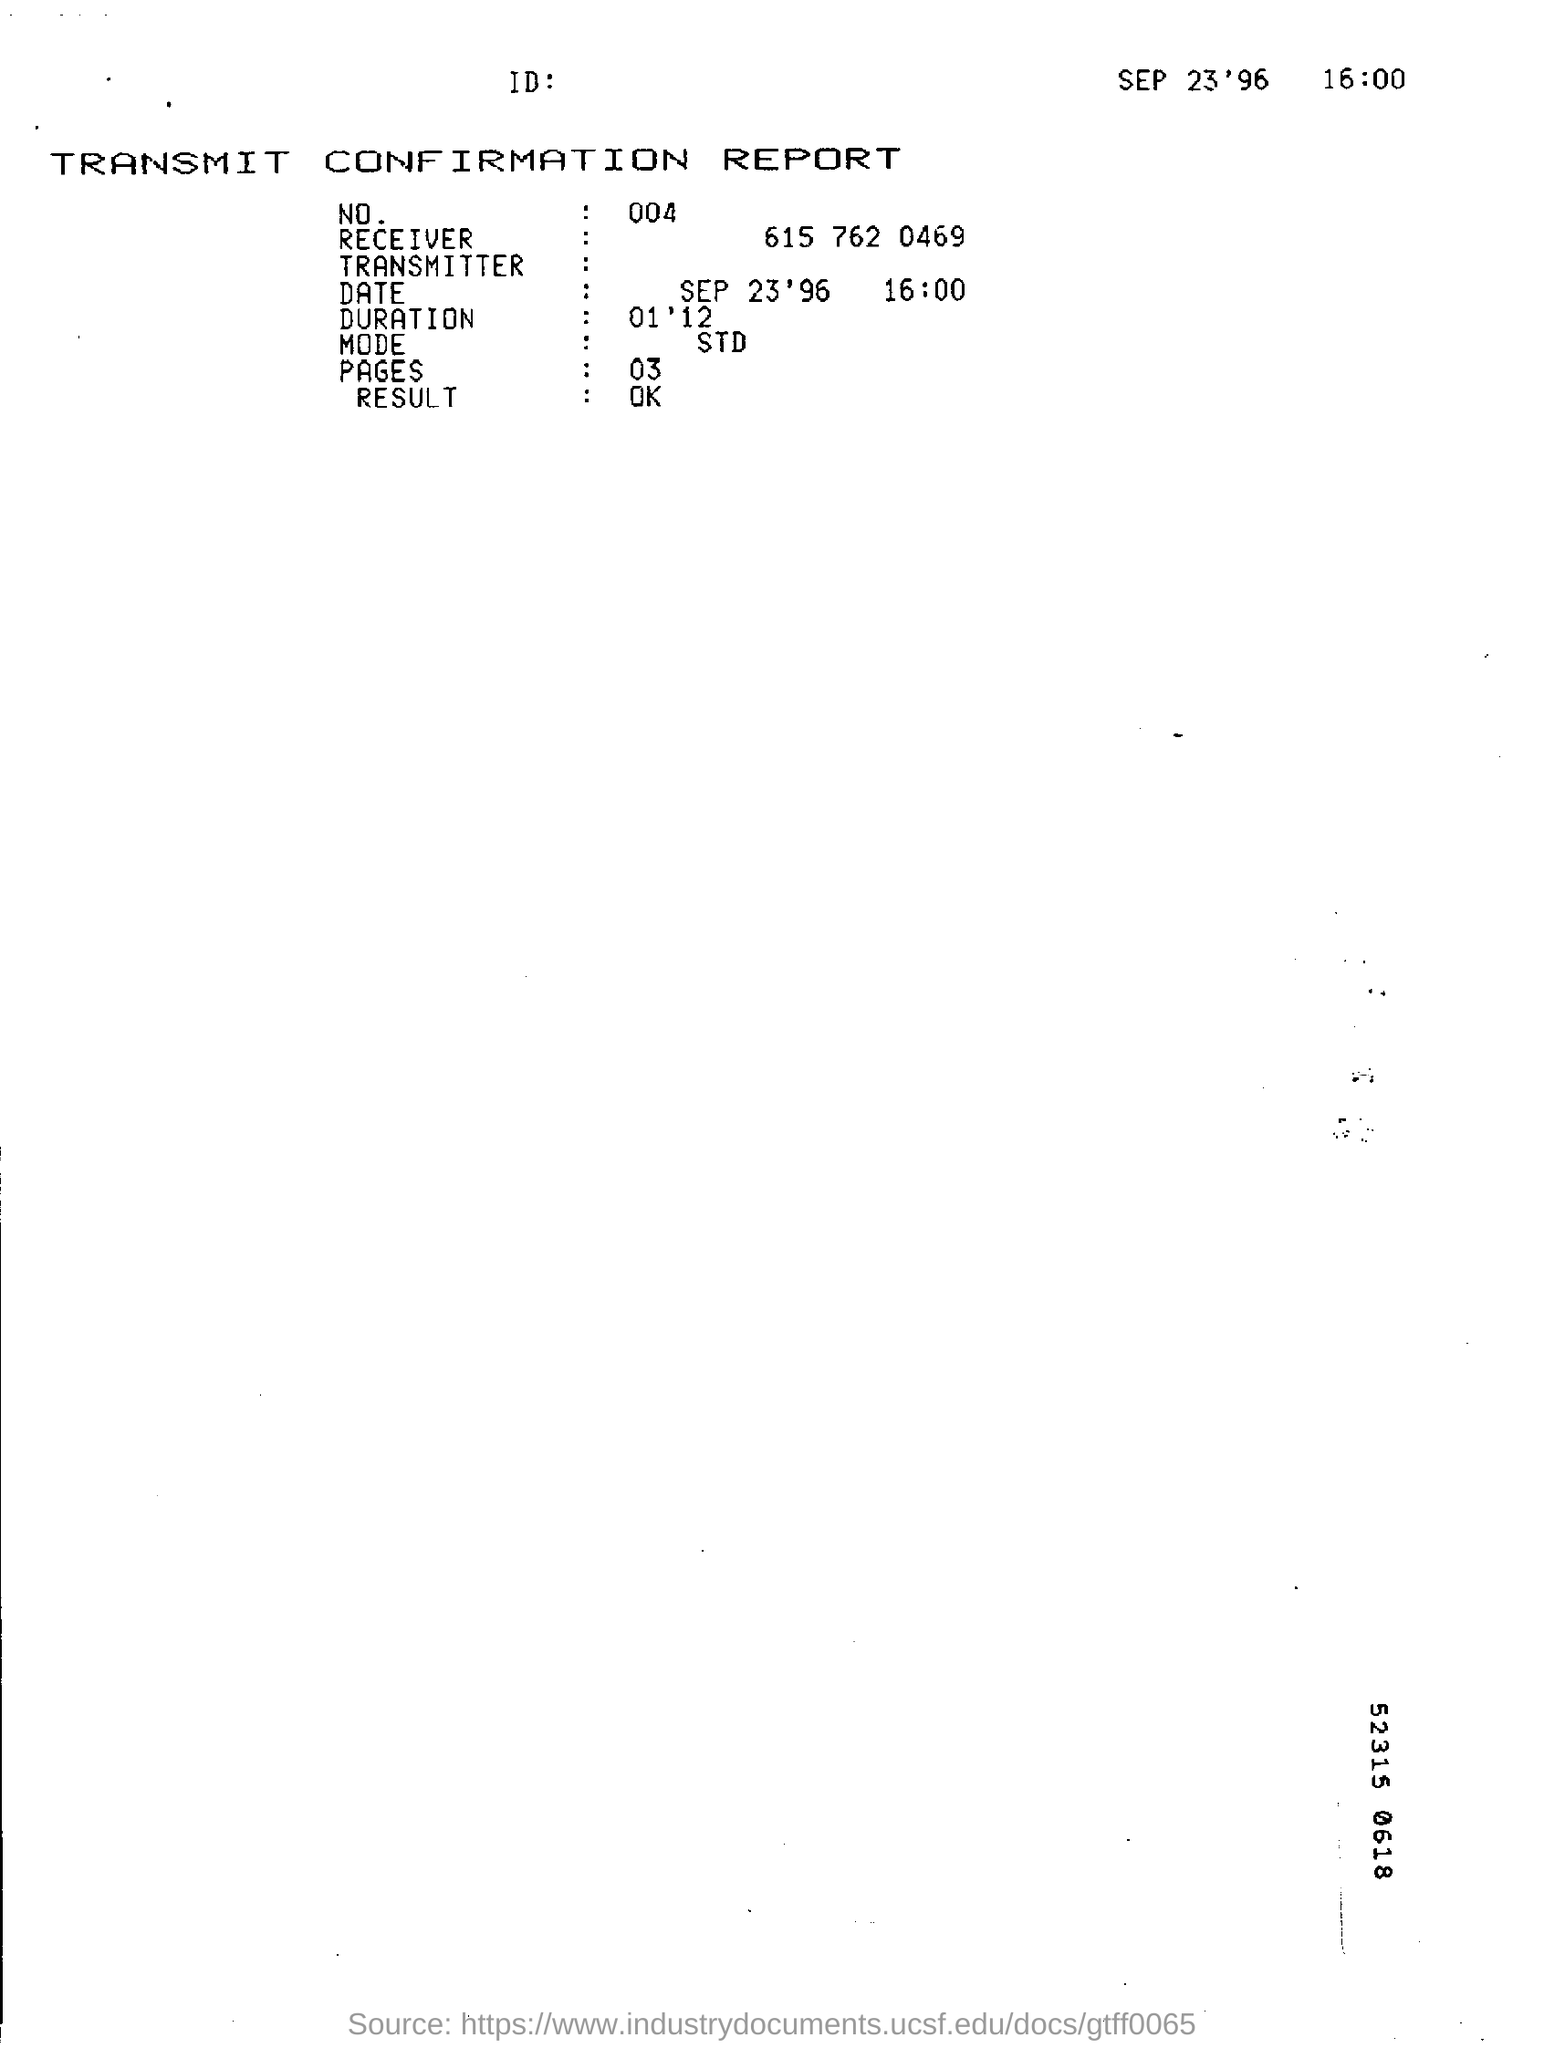What is the time given in the report ?
Your answer should be compact. 16:00. What is the name of the report ?
Keep it short and to the point. Transmit confirmation report. How many pages are there in the report ?
Give a very brief answer. 03. What is the result shown in the report ?
Your response must be concise. Ok. What is the duration time mentioned in the report ?
Offer a terse response. 01' 12. What is the no.of the given report ?
Ensure brevity in your answer.  004. 